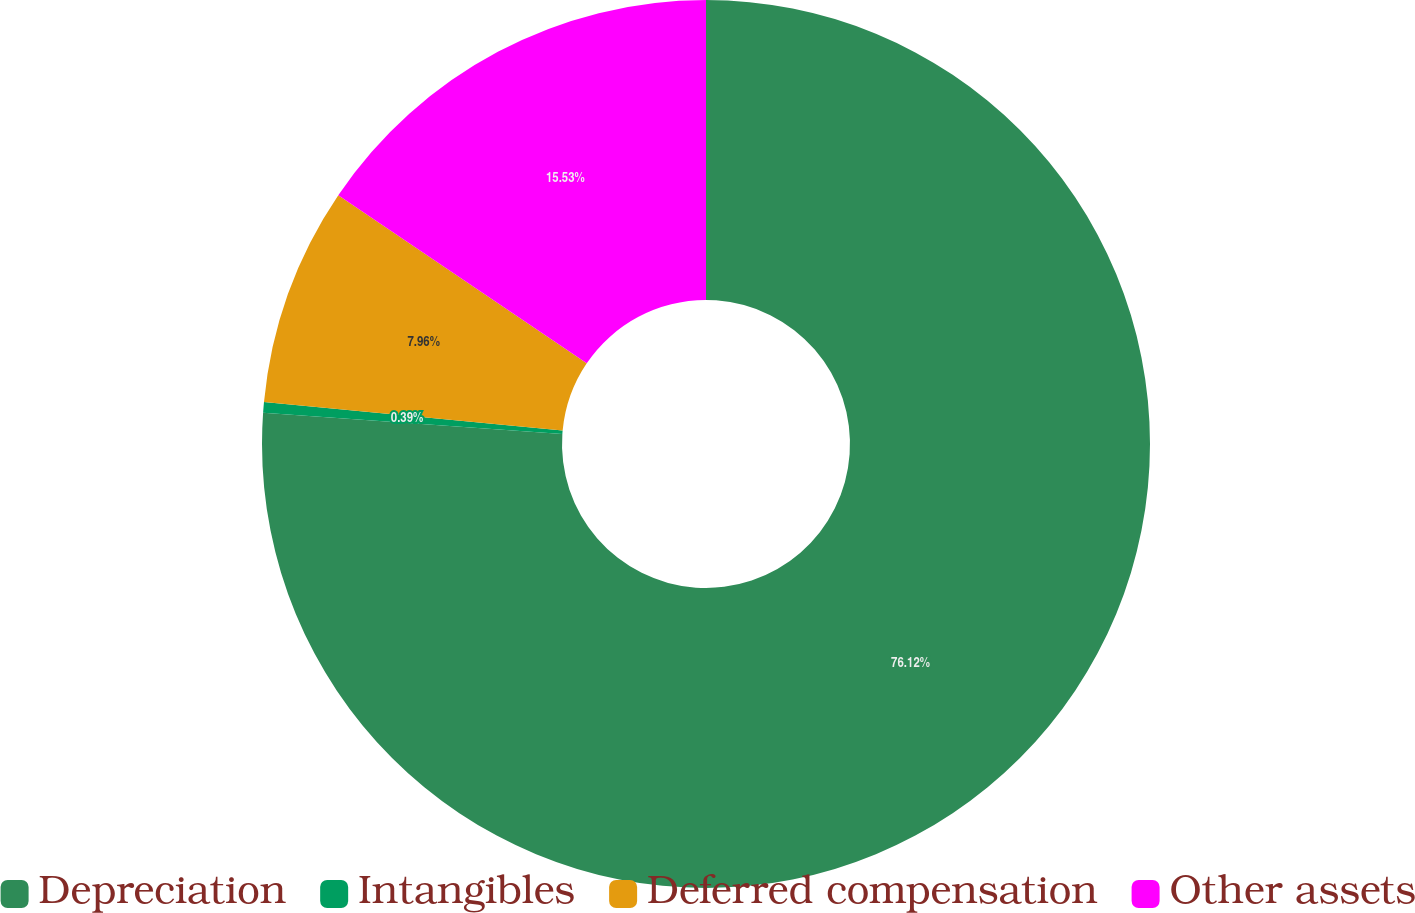Convert chart. <chart><loc_0><loc_0><loc_500><loc_500><pie_chart><fcel>Depreciation<fcel>Intangibles<fcel>Deferred compensation<fcel>Other assets<nl><fcel>76.11%<fcel>0.39%<fcel>7.96%<fcel>15.53%<nl></chart> 